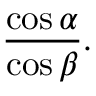<formula> <loc_0><loc_0><loc_500><loc_500>{ \frac { \cos \alpha } { \cos \beta } } .</formula> 